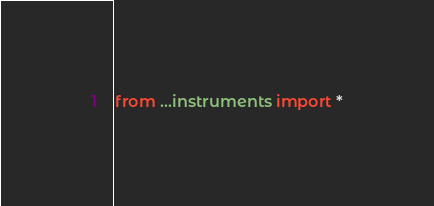<code> <loc_0><loc_0><loc_500><loc_500><_Python_>from ...instruments import *</code> 